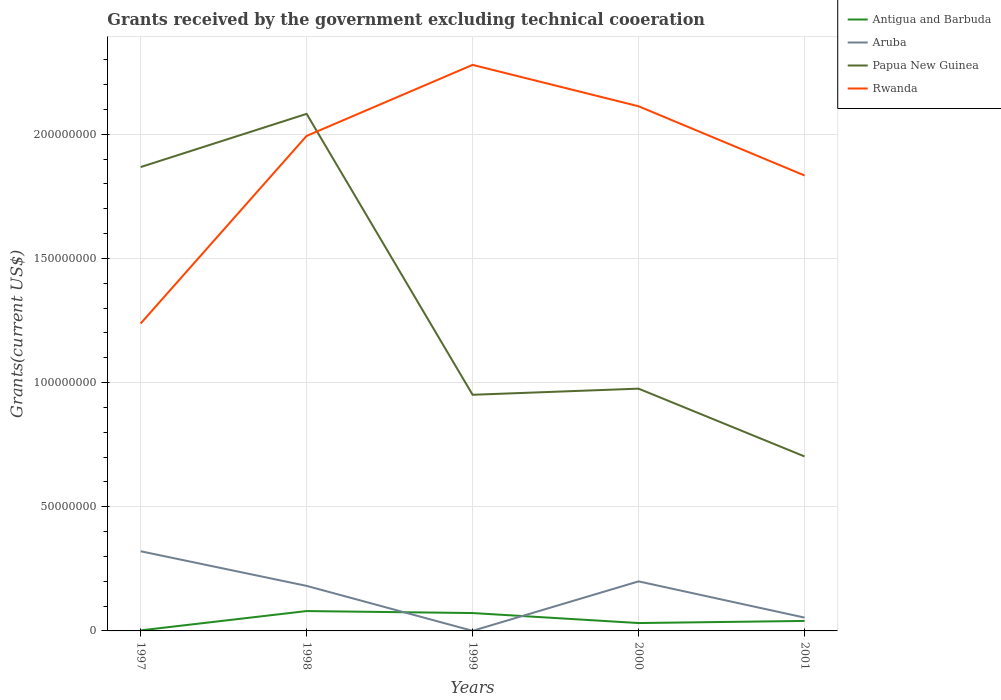Does the line corresponding to Aruba intersect with the line corresponding to Antigua and Barbuda?
Offer a very short reply. Yes. Is the number of lines equal to the number of legend labels?
Ensure brevity in your answer.  Yes. Across all years, what is the maximum total grants received by the government in Aruba?
Your answer should be compact. 4.00e+04. What is the total total grants received by the government in Aruba in the graph?
Keep it short and to the point. -1.81e+06. What is the difference between the highest and the second highest total grants received by the government in Rwanda?
Offer a very short reply. 1.04e+08. Is the total grants received by the government in Aruba strictly greater than the total grants received by the government in Antigua and Barbuda over the years?
Ensure brevity in your answer.  No. How many years are there in the graph?
Provide a succinct answer. 5. Are the values on the major ticks of Y-axis written in scientific E-notation?
Offer a very short reply. No. What is the title of the graph?
Offer a terse response. Grants received by the government excluding technical cooeration. What is the label or title of the X-axis?
Offer a very short reply. Years. What is the label or title of the Y-axis?
Ensure brevity in your answer.  Grants(current US$). What is the Grants(current US$) of Antigua and Barbuda in 1997?
Provide a short and direct response. 2.20e+05. What is the Grants(current US$) of Aruba in 1997?
Offer a terse response. 3.21e+07. What is the Grants(current US$) of Papua New Guinea in 1997?
Provide a succinct answer. 1.87e+08. What is the Grants(current US$) of Rwanda in 1997?
Your response must be concise. 1.24e+08. What is the Grants(current US$) of Aruba in 1998?
Ensure brevity in your answer.  1.81e+07. What is the Grants(current US$) in Papua New Guinea in 1998?
Your answer should be compact. 2.08e+08. What is the Grants(current US$) of Rwanda in 1998?
Offer a very short reply. 1.99e+08. What is the Grants(current US$) of Antigua and Barbuda in 1999?
Your answer should be compact. 7.20e+06. What is the Grants(current US$) in Aruba in 1999?
Your answer should be compact. 4.00e+04. What is the Grants(current US$) in Papua New Guinea in 1999?
Your answer should be compact. 9.51e+07. What is the Grants(current US$) of Rwanda in 1999?
Your answer should be compact. 2.28e+08. What is the Grants(current US$) in Antigua and Barbuda in 2000?
Your answer should be very brief. 3.17e+06. What is the Grants(current US$) in Aruba in 2000?
Give a very brief answer. 2.00e+07. What is the Grants(current US$) of Papua New Guinea in 2000?
Your answer should be compact. 9.76e+07. What is the Grants(current US$) in Rwanda in 2000?
Your response must be concise. 2.11e+08. What is the Grants(current US$) in Antigua and Barbuda in 2001?
Make the answer very short. 4.02e+06. What is the Grants(current US$) in Aruba in 2001?
Give a very brief answer. 5.37e+06. What is the Grants(current US$) of Papua New Guinea in 2001?
Make the answer very short. 7.03e+07. What is the Grants(current US$) of Rwanda in 2001?
Offer a terse response. 1.83e+08. Across all years, what is the maximum Grants(current US$) in Antigua and Barbuda?
Your response must be concise. 8.00e+06. Across all years, what is the maximum Grants(current US$) in Aruba?
Your response must be concise. 3.21e+07. Across all years, what is the maximum Grants(current US$) in Papua New Guinea?
Provide a short and direct response. 2.08e+08. Across all years, what is the maximum Grants(current US$) in Rwanda?
Give a very brief answer. 2.28e+08. Across all years, what is the minimum Grants(current US$) in Papua New Guinea?
Ensure brevity in your answer.  7.03e+07. Across all years, what is the minimum Grants(current US$) of Rwanda?
Keep it short and to the point. 1.24e+08. What is the total Grants(current US$) in Antigua and Barbuda in the graph?
Offer a very short reply. 2.26e+07. What is the total Grants(current US$) of Aruba in the graph?
Make the answer very short. 7.56e+07. What is the total Grants(current US$) of Papua New Guinea in the graph?
Your answer should be compact. 6.58e+08. What is the total Grants(current US$) in Rwanda in the graph?
Ensure brevity in your answer.  9.46e+08. What is the difference between the Grants(current US$) in Antigua and Barbuda in 1997 and that in 1998?
Provide a short and direct response. -7.78e+06. What is the difference between the Grants(current US$) of Aruba in 1997 and that in 1998?
Your answer should be very brief. 1.39e+07. What is the difference between the Grants(current US$) of Papua New Guinea in 1997 and that in 1998?
Offer a terse response. -2.14e+07. What is the difference between the Grants(current US$) in Rwanda in 1997 and that in 1998?
Make the answer very short. -7.56e+07. What is the difference between the Grants(current US$) of Antigua and Barbuda in 1997 and that in 1999?
Your answer should be compact. -6.98e+06. What is the difference between the Grants(current US$) in Aruba in 1997 and that in 1999?
Offer a terse response. 3.20e+07. What is the difference between the Grants(current US$) in Papua New Guinea in 1997 and that in 1999?
Your answer should be compact. 9.17e+07. What is the difference between the Grants(current US$) of Rwanda in 1997 and that in 1999?
Offer a terse response. -1.04e+08. What is the difference between the Grants(current US$) of Antigua and Barbuda in 1997 and that in 2000?
Provide a short and direct response. -2.95e+06. What is the difference between the Grants(current US$) in Aruba in 1997 and that in 2000?
Ensure brevity in your answer.  1.21e+07. What is the difference between the Grants(current US$) of Papua New Guinea in 1997 and that in 2000?
Your answer should be very brief. 8.92e+07. What is the difference between the Grants(current US$) in Rwanda in 1997 and that in 2000?
Offer a terse response. -8.75e+07. What is the difference between the Grants(current US$) of Antigua and Barbuda in 1997 and that in 2001?
Your response must be concise. -3.80e+06. What is the difference between the Grants(current US$) in Aruba in 1997 and that in 2001?
Your answer should be very brief. 2.67e+07. What is the difference between the Grants(current US$) of Papua New Guinea in 1997 and that in 2001?
Your answer should be very brief. 1.17e+08. What is the difference between the Grants(current US$) in Rwanda in 1997 and that in 2001?
Provide a succinct answer. -5.96e+07. What is the difference between the Grants(current US$) of Antigua and Barbuda in 1998 and that in 1999?
Ensure brevity in your answer.  8.00e+05. What is the difference between the Grants(current US$) of Aruba in 1998 and that in 1999?
Offer a very short reply. 1.81e+07. What is the difference between the Grants(current US$) of Papua New Guinea in 1998 and that in 1999?
Offer a terse response. 1.13e+08. What is the difference between the Grants(current US$) in Rwanda in 1998 and that in 1999?
Your response must be concise. -2.86e+07. What is the difference between the Grants(current US$) in Antigua and Barbuda in 1998 and that in 2000?
Ensure brevity in your answer.  4.83e+06. What is the difference between the Grants(current US$) in Aruba in 1998 and that in 2000?
Your answer should be very brief. -1.81e+06. What is the difference between the Grants(current US$) of Papua New Guinea in 1998 and that in 2000?
Ensure brevity in your answer.  1.11e+08. What is the difference between the Grants(current US$) of Rwanda in 1998 and that in 2000?
Provide a succinct answer. -1.19e+07. What is the difference between the Grants(current US$) of Antigua and Barbuda in 1998 and that in 2001?
Your answer should be compact. 3.98e+06. What is the difference between the Grants(current US$) in Aruba in 1998 and that in 2001?
Your answer should be compact. 1.28e+07. What is the difference between the Grants(current US$) in Papua New Guinea in 1998 and that in 2001?
Your answer should be compact. 1.38e+08. What is the difference between the Grants(current US$) in Rwanda in 1998 and that in 2001?
Provide a succinct answer. 1.59e+07. What is the difference between the Grants(current US$) of Antigua and Barbuda in 1999 and that in 2000?
Give a very brief answer. 4.03e+06. What is the difference between the Grants(current US$) in Aruba in 1999 and that in 2000?
Make the answer very short. -1.99e+07. What is the difference between the Grants(current US$) of Papua New Guinea in 1999 and that in 2000?
Offer a very short reply. -2.47e+06. What is the difference between the Grants(current US$) in Rwanda in 1999 and that in 2000?
Your response must be concise. 1.67e+07. What is the difference between the Grants(current US$) of Antigua and Barbuda in 1999 and that in 2001?
Give a very brief answer. 3.18e+06. What is the difference between the Grants(current US$) in Aruba in 1999 and that in 2001?
Your response must be concise. -5.33e+06. What is the difference between the Grants(current US$) in Papua New Guinea in 1999 and that in 2001?
Offer a terse response. 2.48e+07. What is the difference between the Grants(current US$) in Rwanda in 1999 and that in 2001?
Your answer should be compact. 4.45e+07. What is the difference between the Grants(current US$) in Antigua and Barbuda in 2000 and that in 2001?
Keep it short and to the point. -8.50e+05. What is the difference between the Grants(current US$) of Aruba in 2000 and that in 2001?
Give a very brief answer. 1.46e+07. What is the difference between the Grants(current US$) of Papua New Guinea in 2000 and that in 2001?
Your answer should be compact. 2.73e+07. What is the difference between the Grants(current US$) in Rwanda in 2000 and that in 2001?
Offer a terse response. 2.79e+07. What is the difference between the Grants(current US$) in Antigua and Barbuda in 1997 and the Grants(current US$) in Aruba in 1998?
Your answer should be compact. -1.79e+07. What is the difference between the Grants(current US$) of Antigua and Barbuda in 1997 and the Grants(current US$) of Papua New Guinea in 1998?
Your response must be concise. -2.08e+08. What is the difference between the Grants(current US$) in Antigua and Barbuda in 1997 and the Grants(current US$) in Rwanda in 1998?
Your answer should be very brief. -1.99e+08. What is the difference between the Grants(current US$) in Aruba in 1997 and the Grants(current US$) in Papua New Guinea in 1998?
Provide a succinct answer. -1.76e+08. What is the difference between the Grants(current US$) in Aruba in 1997 and the Grants(current US$) in Rwanda in 1998?
Offer a very short reply. -1.67e+08. What is the difference between the Grants(current US$) in Papua New Guinea in 1997 and the Grants(current US$) in Rwanda in 1998?
Give a very brief answer. -1.26e+07. What is the difference between the Grants(current US$) of Antigua and Barbuda in 1997 and the Grants(current US$) of Aruba in 1999?
Offer a terse response. 1.80e+05. What is the difference between the Grants(current US$) of Antigua and Barbuda in 1997 and the Grants(current US$) of Papua New Guinea in 1999?
Offer a very short reply. -9.49e+07. What is the difference between the Grants(current US$) of Antigua and Barbuda in 1997 and the Grants(current US$) of Rwanda in 1999?
Your answer should be very brief. -2.28e+08. What is the difference between the Grants(current US$) of Aruba in 1997 and the Grants(current US$) of Papua New Guinea in 1999?
Keep it short and to the point. -6.30e+07. What is the difference between the Grants(current US$) in Aruba in 1997 and the Grants(current US$) in Rwanda in 1999?
Offer a terse response. -1.96e+08. What is the difference between the Grants(current US$) in Papua New Guinea in 1997 and the Grants(current US$) in Rwanda in 1999?
Make the answer very short. -4.12e+07. What is the difference between the Grants(current US$) in Antigua and Barbuda in 1997 and the Grants(current US$) in Aruba in 2000?
Make the answer very short. -1.97e+07. What is the difference between the Grants(current US$) of Antigua and Barbuda in 1997 and the Grants(current US$) of Papua New Guinea in 2000?
Your response must be concise. -9.74e+07. What is the difference between the Grants(current US$) in Antigua and Barbuda in 1997 and the Grants(current US$) in Rwanda in 2000?
Your answer should be compact. -2.11e+08. What is the difference between the Grants(current US$) in Aruba in 1997 and the Grants(current US$) in Papua New Guinea in 2000?
Make the answer very short. -6.55e+07. What is the difference between the Grants(current US$) in Aruba in 1997 and the Grants(current US$) in Rwanda in 2000?
Your response must be concise. -1.79e+08. What is the difference between the Grants(current US$) of Papua New Guinea in 1997 and the Grants(current US$) of Rwanda in 2000?
Your answer should be very brief. -2.45e+07. What is the difference between the Grants(current US$) in Antigua and Barbuda in 1997 and the Grants(current US$) in Aruba in 2001?
Offer a very short reply. -5.15e+06. What is the difference between the Grants(current US$) of Antigua and Barbuda in 1997 and the Grants(current US$) of Papua New Guinea in 2001?
Provide a short and direct response. -7.00e+07. What is the difference between the Grants(current US$) of Antigua and Barbuda in 1997 and the Grants(current US$) of Rwanda in 2001?
Ensure brevity in your answer.  -1.83e+08. What is the difference between the Grants(current US$) in Aruba in 1997 and the Grants(current US$) in Papua New Guinea in 2001?
Keep it short and to the point. -3.82e+07. What is the difference between the Grants(current US$) in Aruba in 1997 and the Grants(current US$) in Rwanda in 2001?
Ensure brevity in your answer.  -1.51e+08. What is the difference between the Grants(current US$) of Papua New Guinea in 1997 and the Grants(current US$) of Rwanda in 2001?
Give a very brief answer. 3.39e+06. What is the difference between the Grants(current US$) of Antigua and Barbuda in 1998 and the Grants(current US$) of Aruba in 1999?
Keep it short and to the point. 7.96e+06. What is the difference between the Grants(current US$) of Antigua and Barbuda in 1998 and the Grants(current US$) of Papua New Guinea in 1999?
Make the answer very short. -8.71e+07. What is the difference between the Grants(current US$) in Antigua and Barbuda in 1998 and the Grants(current US$) in Rwanda in 1999?
Keep it short and to the point. -2.20e+08. What is the difference between the Grants(current US$) in Aruba in 1998 and the Grants(current US$) in Papua New Guinea in 1999?
Provide a short and direct response. -7.70e+07. What is the difference between the Grants(current US$) in Aruba in 1998 and the Grants(current US$) in Rwanda in 1999?
Ensure brevity in your answer.  -2.10e+08. What is the difference between the Grants(current US$) in Papua New Guinea in 1998 and the Grants(current US$) in Rwanda in 1999?
Make the answer very short. -1.97e+07. What is the difference between the Grants(current US$) in Antigua and Barbuda in 1998 and the Grants(current US$) in Aruba in 2000?
Provide a short and direct response. -1.20e+07. What is the difference between the Grants(current US$) of Antigua and Barbuda in 1998 and the Grants(current US$) of Papua New Guinea in 2000?
Your answer should be very brief. -8.96e+07. What is the difference between the Grants(current US$) in Antigua and Barbuda in 1998 and the Grants(current US$) in Rwanda in 2000?
Your answer should be compact. -2.03e+08. What is the difference between the Grants(current US$) in Aruba in 1998 and the Grants(current US$) in Papua New Guinea in 2000?
Keep it short and to the point. -7.94e+07. What is the difference between the Grants(current US$) of Aruba in 1998 and the Grants(current US$) of Rwanda in 2000?
Provide a succinct answer. -1.93e+08. What is the difference between the Grants(current US$) in Papua New Guinea in 1998 and the Grants(current US$) in Rwanda in 2000?
Your answer should be very brief. -3.06e+06. What is the difference between the Grants(current US$) in Antigua and Barbuda in 1998 and the Grants(current US$) in Aruba in 2001?
Keep it short and to the point. 2.63e+06. What is the difference between the Grants(current US$) of Antigua and Barbuda in 1998 and the Grants(current US$) of Papua New Guinea in 2001?
Provide a succinct answer. -6.23e+07. What is the difference between the Grants(current US$) of Antigua and Barbuda in 1998 and the Grants(current US$) of Rwanda in 2001?
Offer a terse response. -1.75e+08. What is the difference between the Grants(current US$) of Aruba in 1998 and the Grants(current US$) of Papua New Guinea in 2001?
Offer a terse response. -5.21e+07. What is the difference between the Grants(current US$) of Aruba in 1998 and the Grants(current US$) of Rwanda in 2001?
Offer a terse response. -1.65e+08. What is the difference between the Grants(current US$) in Papua New Guinea in 1998 and the Grants(current US$) in Rwanda in 2001?
Offer a terse response. 2.48e+07. What is the difference between the Grants(current US$) in Antigua and Barbuda in 1999 and the Grants(current US$) in Aruba in 2000?
Ensure brevity in your answer.  -1.28e+07. What is the difference between the Grants(current US$) of Antigua and Barbuda in 1999 and the Grants(current US$) of Papua New Guinea in 2000?
Offer a very short reply. -9.04e+07. What is the difference between the Grants(current US$) of Antigua and Barbuda in 1999 and the Grants(current US$) of Rwanda in 2000?
Make the answer very short. -2.04e+08. What is the difference between the Grants(current US$) of Aruba in 1999 and the Grants(current US$) of Papua New Guinea in 2000?
Your response must be concise. -9.75e+07. What is the difference between the Grants(current US$) of Aruba in 1999 and the Grants(current US$) of Rwanda in 2000?
Provide a succinct answer. -2.11e+08. What is the difference between the Grants(current US$) in Papua New Guinea in 1999 and the Grants(current US$) in Rwanda in 2000?
Provide a short and direct response. -1.16e+08. What is the difference between the Grants(current US$) of Antigua and Barbuda in 1999 and the Grants(current US$) of Aruba in 2001?
Give a very brief answer. 1.83e+06. What is the difference between the Grants(current US$) of Antigua and Barbuda in 1999 and the Grants(current US$) of Papua New Guinea in 2001?
Offer a terse response. -6.31e+07. What is the difference between the Grants(current US$) of Antigua and Barbuda in 1999 and the Grants(current US$) of Rwanda in 2001?
Make the answer very short. -1.76e+08. What is the difference between the Grants(current US$) in Aruba in 1999 and the Grants(current US$) in Papua New Guinea in 2001?
Make the answer very short. -7.02e+07. What is the difference between the Grants(current US$) of Aruba in 1999 and the Grants(current US$) of Rwanda in 2001?
Your response must be concise. -1.83e+08. What is the difference between the Grants(current US$) in Papua New Guinea in 1999 and the Grants(current US$) in Rwanda in 2001?
Your response must be concise. -8.83e+07. What is the difference between the Grants(current US$) of Antigua and Barbuda in 2000 and the Grants(current US$) of Aruba in 2001?
Your answer should be compact. -2.20e+06. What is the difference between the Grants(current US$) of Antigua and Barbuda in 2000 and the Grants(current US$) of Papua New Guinea in 2001?
Provide a succinct answer. -6.71e+07. What is the difference between the Grants(current US$) of Antigua and Barbuda in 2000 and the Grants(current US$) of Rwanda in 2001?
Your answer should be compact. -1.80e+08. What is the difference between the Grants(current US$) of Aruba in 2000 and the Grants(current US$) of Papua New Guinea in 2001?
Provide a succinct answer. -5.03e+07. What is the difference between the Grants(current US$) in Aruba in 2000 and the Grants(current US$) in Rwanda in 2001?
Your response must be concise. -1.63e+08. What is the difference between the Grants(current US$) of Papua New Guinea in 2000 and the Grants(current US$) of Rwanda in 2001?
Your answer should be very brief. -8.59e+07. What is the average Grants(current US$) in Antigua and Barbuda per year?
Keep it short and to the point. 4.52e+06. What is the average Grants(current US$) in Aruba per year?
Your answer should be very brief. 1.51e+07. What is the average Grants(current US$) of Papua New Guinea per year?
Ensure brevity in your answer.  1.32e+08. What is the average Grants(current US$) in Rwanda per year?
Your answer should be compact. 1.89e+08. In the year 1997, what is the difference between the Grants(current US$) in Antigua and Barbuda and Grants(current US$) in Aruba?
Your answer should be very brief. -3.19e+07. In the year 1997, what is the difference between the Grants(current US$) of Antigua and Barbuda and Grants(current US$) of Papua New Guinea?
Your answer should be very brief. -1.87e+08. In the year 1997, what is the difference between the Grants(current US$) in Antigua and Barbuda and Grants(current US$) in Rwanda?
Offer a very short reply. -1.24e+08. In the year 1997, what is the difference between the Grants(current US$) in Aruba and Grants(current US$) in Papua New Guinea?
Give a very brief answer. -1.55e+08. In the year 1997, what is the difference between the Grants(current US$) of Aruba and Grants(current US$) of Rwanda?
Provide a succinct answer. -9.17e+07. In the year 1997, what is the difference between the Grants(current US$) in Papua New Guinea and Grants(current US$) in Rwanda?
Provide a succinct answer. 6.30e+07. In the year 1998, what is the difference between the Grants(current US$) in Antigua and Barbuda and Grants(current US$) in Aruba?
Keep it short and to the point. -1.01e+07. In the year 1998, what is the difference between the Grants(current US$) of Antigua and Barbuda and Grants(current US$) of Papua New Guinea?
Offer a terse response. -2.00e+08. In the year 1998, what is the difference between the Grants(current US$) of Antigua and Barbuda and Grants(current US$) of Rwanda?
Provide a succinct answer. -1.91e+08. In the year 1998, what is the difference between the Grants(current US$) in Aruba and Grants(current US$) in Papua New Guinea?
Your answer should be compact. -1.90e+08. In the year 1998, what is the difference between the Grants(current US$) of Aruba and Grants(current US$) of Rwanda?
Provide a succinct answer. -1.81e+08. In the year 1998, what is the difference between the Grants(current US$) in Papua New Guinea and Grants(current US$) in Rwanda?
Your answer should be compact. 8.87e+06. In the year 1999, what is the difference between the Grants(current US$) of Antigua and Barbuda and Grants(current US$) of Aruba?
Provide a succinct answer. 7.16e+06. In the year 1999, what is the difference between the Grants(current US$) of Antigua and Barbuda and Grants(current US$) of Papua New Guinea?
Your response must be concise. -8.79e+07. In the year 1999, what is the difference between the Grants(current US$) of Antigua and Barbuda and Grants(current US$) of Rwanda?
Provide a succinct answer. -2.21e+08. In the year 1999, what is the difference between the Grants(current US$) of Aruba and Grants(current US$) of Papua New Guinea?
Offer a terse response. -9.51e+07. In the year 1999, what is the difference between the Grants(current US$) of Aruba and Grants(current US$) of Rwanda?
Give a very brief answer. -2.28e+08. In the year 1999, what is the difference between the Grants(current US$) in Papua New Guinea and Grants(current US$) in Rwanda?
Keep it short and to the point. -1.33e+08. In the year 2000, what is the difference between the Grants(current US$) in Antigua and Barbuda and Grants(current US$) in Aruba?
Provide a succinct answer. -1.68e+07. In the year 2000, what is the difference between the Grants(current US$) in Antigua and Barbuda and Grants(current US$) in Papua New Guinea?
Offer a terse response. -9.44e+07. In the year 2000, what is the difference between the Grants(current US$) in Antigua and Barbuda and Grants(current US$) in Rwanda?
Your answer should be compact. -2.08e+08. In the year 2000, what is the difference between the Grants(current US$) of Aruba and Grants(current US$) of Papua New Guinea?
Offer a terse response. -7.76e+07. In the year 2000, what is the difference between the Grants(current US$) of Aruba and Grants(current US$) of Rwanda?
Make the answer very short. -1.91e+08. In the year 2000, what is the difference between the Grants(current US$) of Papua New Guinea and Grants(current US$) of Rwanda?
Keep it short and to the point. -1.14e+08. In the year 2001, what is the difference between the Grants(current US$) of Antigua and Barbuda and Grants(current US$) of Aruba?
Keep it short and to the point. -1.35e+06. In the year 2001, what is the difference between the Grants(current US$) of Antigua and Barbuda and Grants(current US$) of Papua New Guinea?
Make the answer very short. -6.62e+07. In the year 2001, what is the difference between the Grants(current US$) of Antigua and Barbuda and Grants(current US$) of Rwanda?
Provide a short and direct response. -1.79e+08. In the year 2001, what is the difference between the Grants(current US$) in Aruba and Grants(current US$) in Papua New Guinea?
Offer a terse response. -6.49e+07. In the year 2001, what is the difference between the Grants(current US$) of Aruba and Grants(current US$) of Rwanda?
Keep it short and to the point. -1.78e+08. In the year 2001, what is the difference between the Grants(current US$) in Papua New Guinea and Grants(current US$) in Rwanda?
Keep it short and to the point. -1.13e+08. What is the ratio of the Grants(current US$) in Antigua and Barbuda in 1997 to that in 1998?
Keep it short and to the point. 0.03. What is the ratio of the Grants(current US$) in Aruba in 1997 to that in 1998?
Offer a very short reply. 1.77. What is the ratio of the Grants(current US$) of Papua New Guinea in 1997 to that in 1998?
Keep it short and to the point. 0.9. What is the ratio of the Grants(current US$) in Rwanda in 1997 to that in 1998?
Your response must be concise. 0.62. What is the ratio of the Grants(current US$) in Antigua and Barbuda in 1997 to that in 1999?
Your response must be concise. 0.03. What is the ratio of the Grants(current US$) of Aruba in 1997 to that in 1999?
Give a very brief answer. 802. What is the ratio of the Grants(current US$) in Papua New Guinea in 1997 to that in 1999?
Offer a very short reply. 1.96. What is the ratio of the Grants(current US$) of Rwanda in 1997 to that in 1999?
Offer a very short reply. 0.54. What is the ratio of the Grants(current US$) of Antigua and Barbuda in 1997 to that in 2000?
Your answer should be very brief. 0.07. What is the ratio of the Grants(current US$) in Aruba in 1997 to that in 2000?
Ensure brevity in your answer.  1.61. What is the ratio of the Grants(current US$) in Papua New Guinea in 1997 to that in 2000?
Your response must be concise. 1.91. What is the ratio of the Grants(current US$) in Rwanda in 1997 to that in 2000?
Give a very brief answer. 0.59. What is the ratio of the Grants(current US$) in Antigua and Barbuda in 1997 to that in 2001?
Make the answer very short. 0.05. What is the ratio of the Grants(current US$) of Aruba in 1997 to that in 2001?
Offer a very short reply. 5.97. What is the ratio of the Grants(current US$) in Papua New Guinea in 1997 to that in 2001?
Keep it short and to the point. 2.66. What is the ratio of the Grants(current US$) in Rwanda in 1997 to that in 2001?
Your answer should be compact. 0.68. What is the ratio of the Grants(current US$) in Antigua and Barbuda in 1998 to that in 1999?
Your answer should be very brief. 1.11. What is the ratio of the Grants(current US$) in Aruba in 1998 to that in 1999?
Offer a terse response. 453.5. What is the ratio of the Grants(current US$) in Papua New Guinea in 1998 to that in 1999?
Ensure brevity in your answer.  2.19. What is the ratio of the Grants(current US$) of Rwanda in 1998 to that in 1999?
Offer a terse response. 0.87. What is the ratio of the Grants(current US$) of Antigua and Barbuda in 1998 to that in 2000?
Your response must be concise. 2.52. What is the ratio of the Grants(current US$) of Aruba in 1998 to that in 2000?
Offer a very short reply. 0.91. What is the ratio of the Grants(current US$) of Papua New Guinea in 1998 to that in 2000?
Give a very brief answer. 2.13. What is the ratio of the Grants(current US$) in Rwanda in 1998 to that in 2000?
Your answer should be very brief. 0.94. What is the ratio of the Grants(current US$) of Antigua and Barbuda in 1998 to that in 2001?
Keep it short and to the point. 1.99. What is the ratio of the Grants(current US$) of Aruba in 1998 to that in 2001?
Make the answer very short. 3.38. What is the ratio of the Grants(current US$) in Papua New Guinea in 1998 to that in 2001?
Ensure brevity in your answer.  2.96. What is the ratio of the Grants(current US$) of Rwanda in 1998 to that in 2001?
Keep it short and to the point. 1.09. What is the ratio of the Grants(current US$) in Antigua and Barbuda in 1999 to that in 2000?
Your answer should be very brief. 2.27. What is the ratio of the Grants(current US$) in Aruba in 1999 to that in 2000?
Give a very brief answer. 0. What is the ratio of the Grants(current US$) in Papua New Guinea in 1999 to that in 2000?
Your answer should be very brief. 0.97. What is the ratio of the Grants(current US$) in Rwanda in 1999 to that in 2000?
Your answer should be very brief. 1.08. What is the ratio of the Grants(current US$) in Antigua and Barbuda in 1999 to that in 2001?
Provide a succinct answer. 1.79. What is the ratio of the Grants(current US$) in Aruba in 1999 to that in 2001?
Your answer should be compact. 0.01. What is the ratio of the Grants(current US$) of Papua New Guinea in 1999 to that in 2001?
Keep it short and to the point. 1.35. What is the ratio of the Grants(current US$) in Rwanda in 1999 to that in 2001?
Offer a very short reply. 1.24. What is the ratio of the Grants(current US$) in Antigua and Barbuda in 2000 to that in 2001?
Keep it short and to the point. 0.79. What is the ratio of the Grants(current US$) in Aruba in 2000 to that in 2001?
Offer a very short reply. 3.72. What is the ratio of the Grants(current US$) of Papua New Guinea in 2000 to that in 2001?
Make the answer very short. 1.39. What is the ratio of the Grants(current US$) in Rwanda in 2000 to that in 2001?
Give a very brief answer. 1.15. What is the difference between the highest and the second highest Grants(current US$) of Aruba?
Give a very brief answer. 1.21e+07. What is the difference between the highest and the second highest Grants(current US$) in Papua New Guinea?
Provide a short and direct response. 2.14e+07. What is the difference between the highest and the second highest Grants(current US$) of Rwanda?
Offer a very short reply. 1.67e+07. What is the difference between the highest and the lowest Grants(current US$) in Antigua and Barbuda?
Make the answer very short. 7.78e+06. What is the difference between the highest and the lowest Grants(current US$) of Aruba?
Your response must be concise. 3.20e+07. What is the difference between the highest and the lowest Grants(current US$) of Papua New Guinea?
Offer a terse response. 1.38e+08. What is the difference between the highest and the lowest Grants(current US$) of Rwanda?
Your answer should be compact. 1.04e+08. 